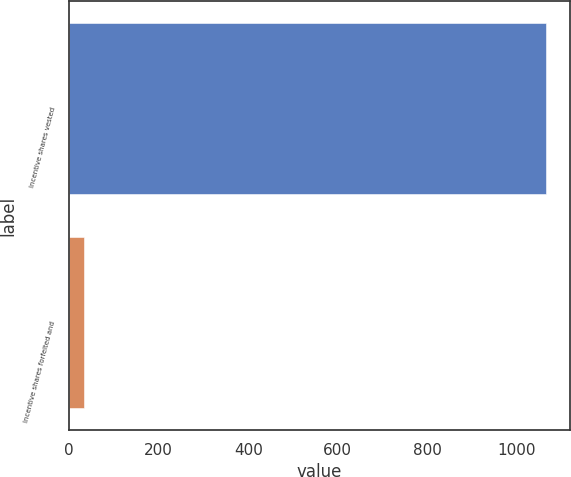Convert chart to OTSL. <chart><loc_0><loc_0><loc_500><loc_500><bar_chart><fcel>Incentive shares vested<fcel>Incentive shares forfeited and<nl><fcel>1066<fcel>32<nl></chart> 